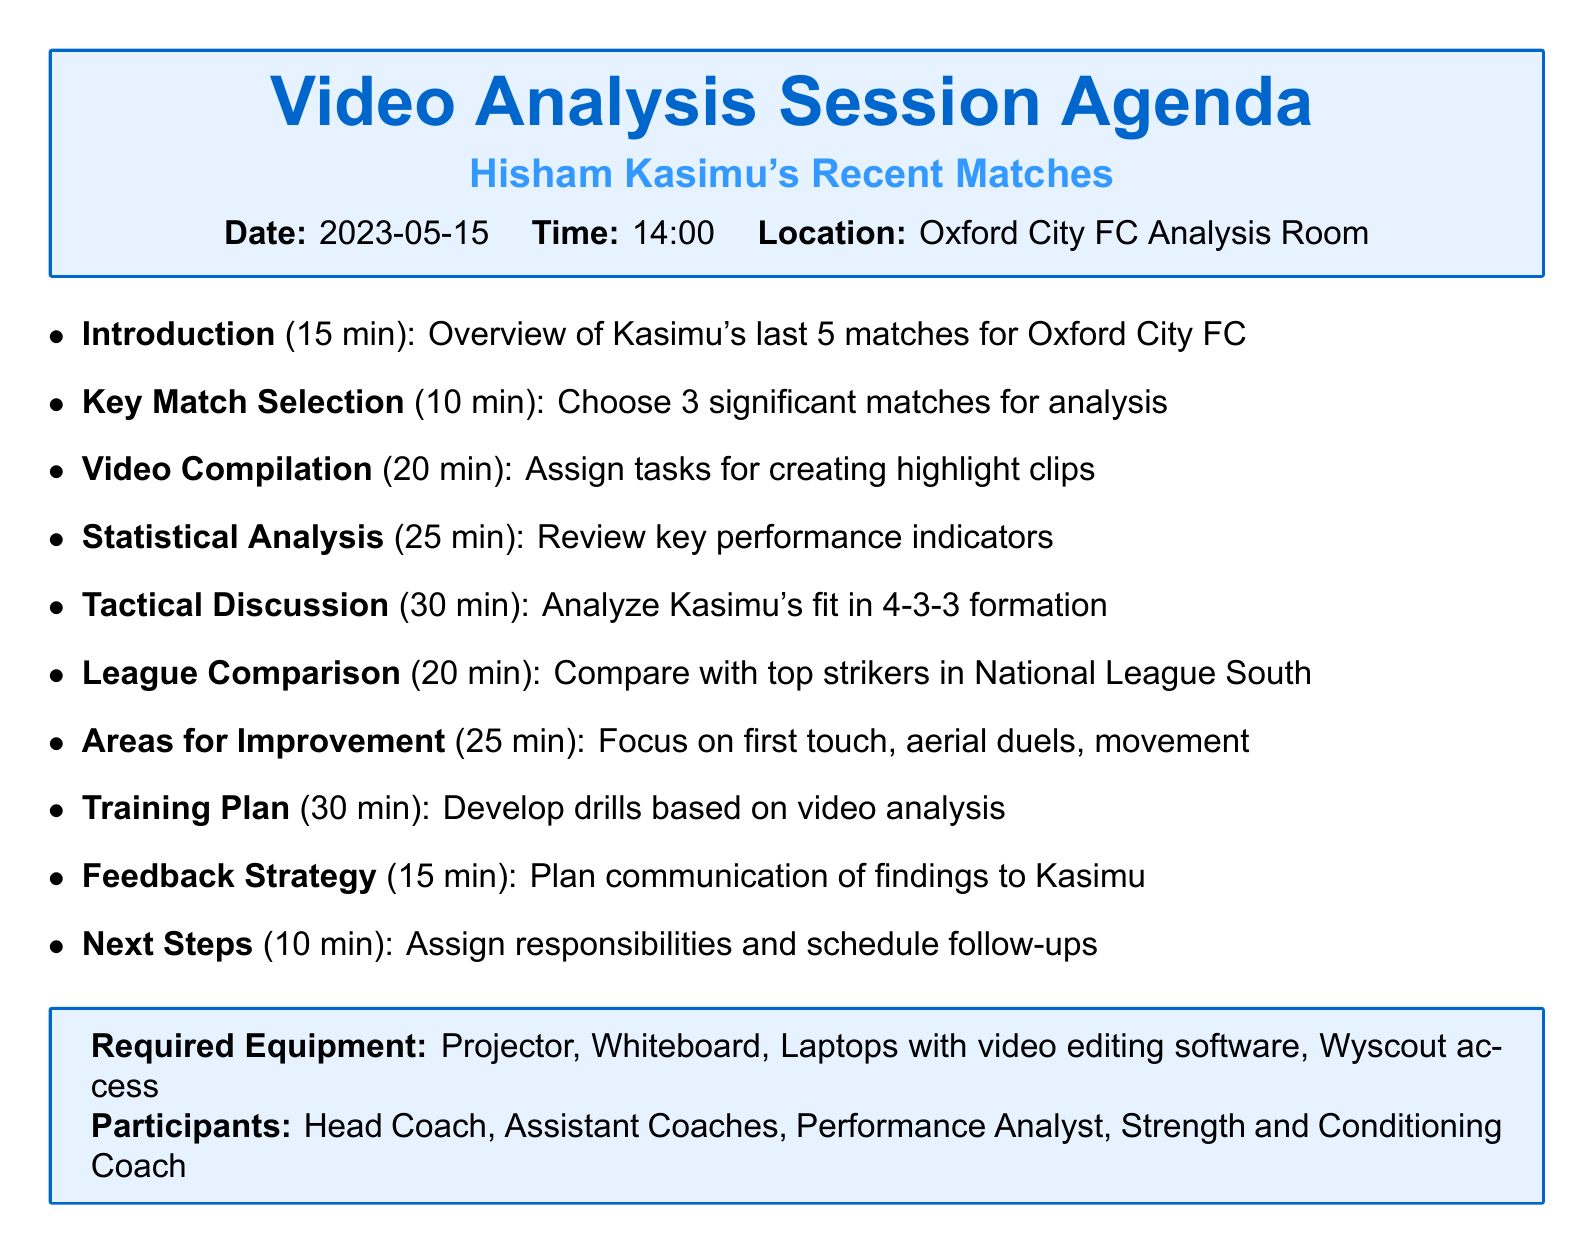What is the date of the video analysis session? The date is specified in the logistics section of the document as "2023-05-15."
Answer: 2023-05-15 How long is the Tactical Discussion scheduled for? The duration of the Tactical Discussion is outlined in the agenda items, specifically mentioned as "30 minutes."
Answer: 30 minutes Which matches are chosen for in-depth analysis? The document lists the three matches selected for analysis: Oxford City vs Havant & Waterlooville, Oxford City vs Dartford, and Oxford City vs Chippenham Town.
Answer: Oxford City vs Havant & Waterlooville, Oxford City vs Dartford, Oxford City vs Chippenham Town What is one area identified for improvement in Kasimu's game? The areas for improvement include first touch, aerial duels, and off-the-ball movement, which are enumerated in the relevant agenda item.
Answer: First touch Who is part of the participants in the video analysis session? The participants are mentioned in the logistics section, including Head Coach, Assistant Coaches, Performance Analyst, and Strength and Conditioning Coach.
Answer: Head Coach, Assistant Coaches, Performance Analyst, Strength and Conditioning Coach What equipment is required for the session? The logistics section specifies the required equipment: Projector, Whiteboard, Laptops with video editing software, and Wyscout access.
Answer: Projector, Whiteboard, Laptops with video editing software, Wyscout access How many minutes are allocated for Statistical Analysis Review? The duration for the Statistical Analysis Review is noted in the agenda, specifically stated as "25 minutes."
Answer: 25 minutes What is the main focus of the Training Plan Development agenda item? The agenda item for Training Plan Development focuses on brainstorming specific drills and exercises based on insights from the video analysis.
Answer: Specific drills and exercises 